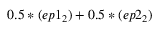<formula> <loc_0><loc_0><loc_500><loc_500>0 . 5 * ( e p 1 _ { 2 } ) + 0 . 5 * ( e p 2 _ { 2 } )</formula> 